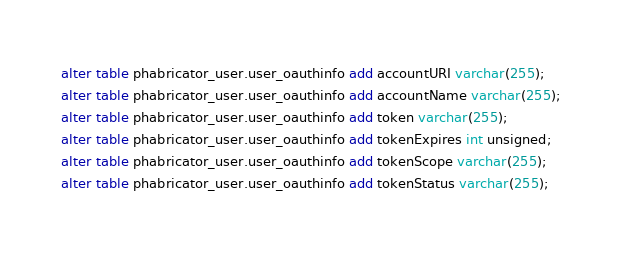Convert code to text. <code><loc_0><loc_0><loc_500><loc_500><_SQL_>alter table phabricator_user.user_oauthinfo add accountURI varchar(255);
alter table phabricator_user.user_oauthinfo add accountName varchar(255);
alter table phabricator_user.user_oauthinfo add token varchar(255);
alter table phabricator_user.user_oauthinfo add tokenExpires int unsigned;
alter table phabricator_user.user_oauthinfo add tokenScope varchar(255);
alter table phabricator_user.user_oauthinfo add tokenStatus varchar(255);
</code> 